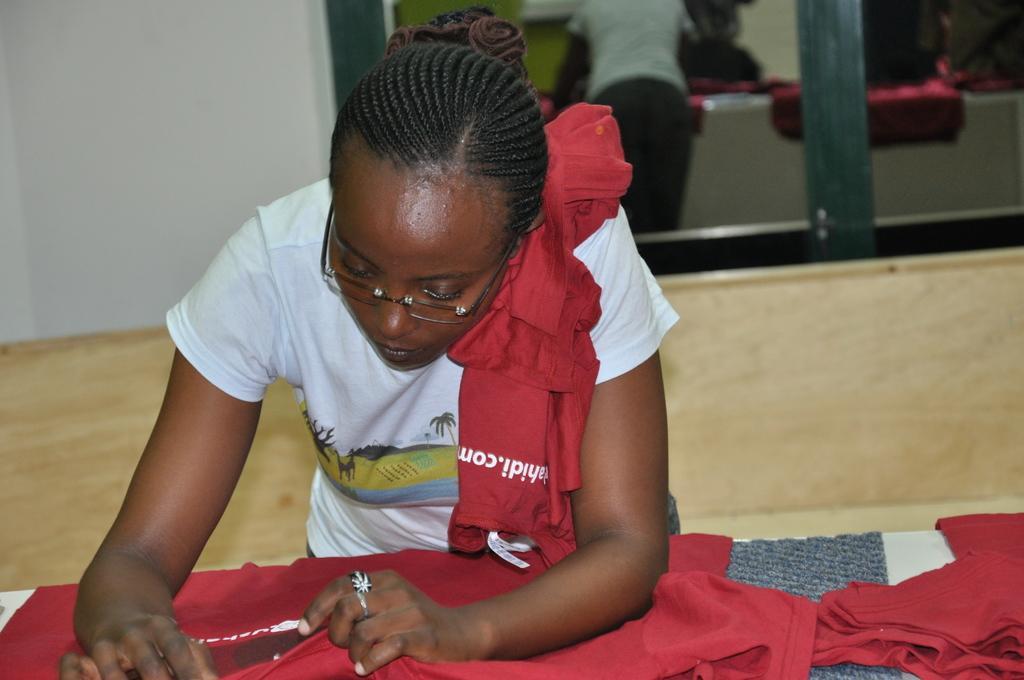Please provide a concise description of this image. In this image we can see a woman standing and holding a cloth, in the background, we can see a window and the wall, in the window we can see a reflection of the woman. 